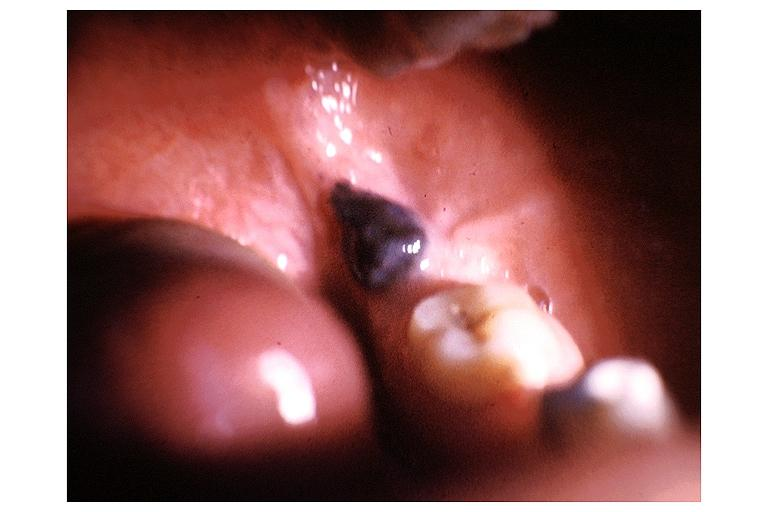s stein leventhal present?
Answer the question using a single word or phrase. No 